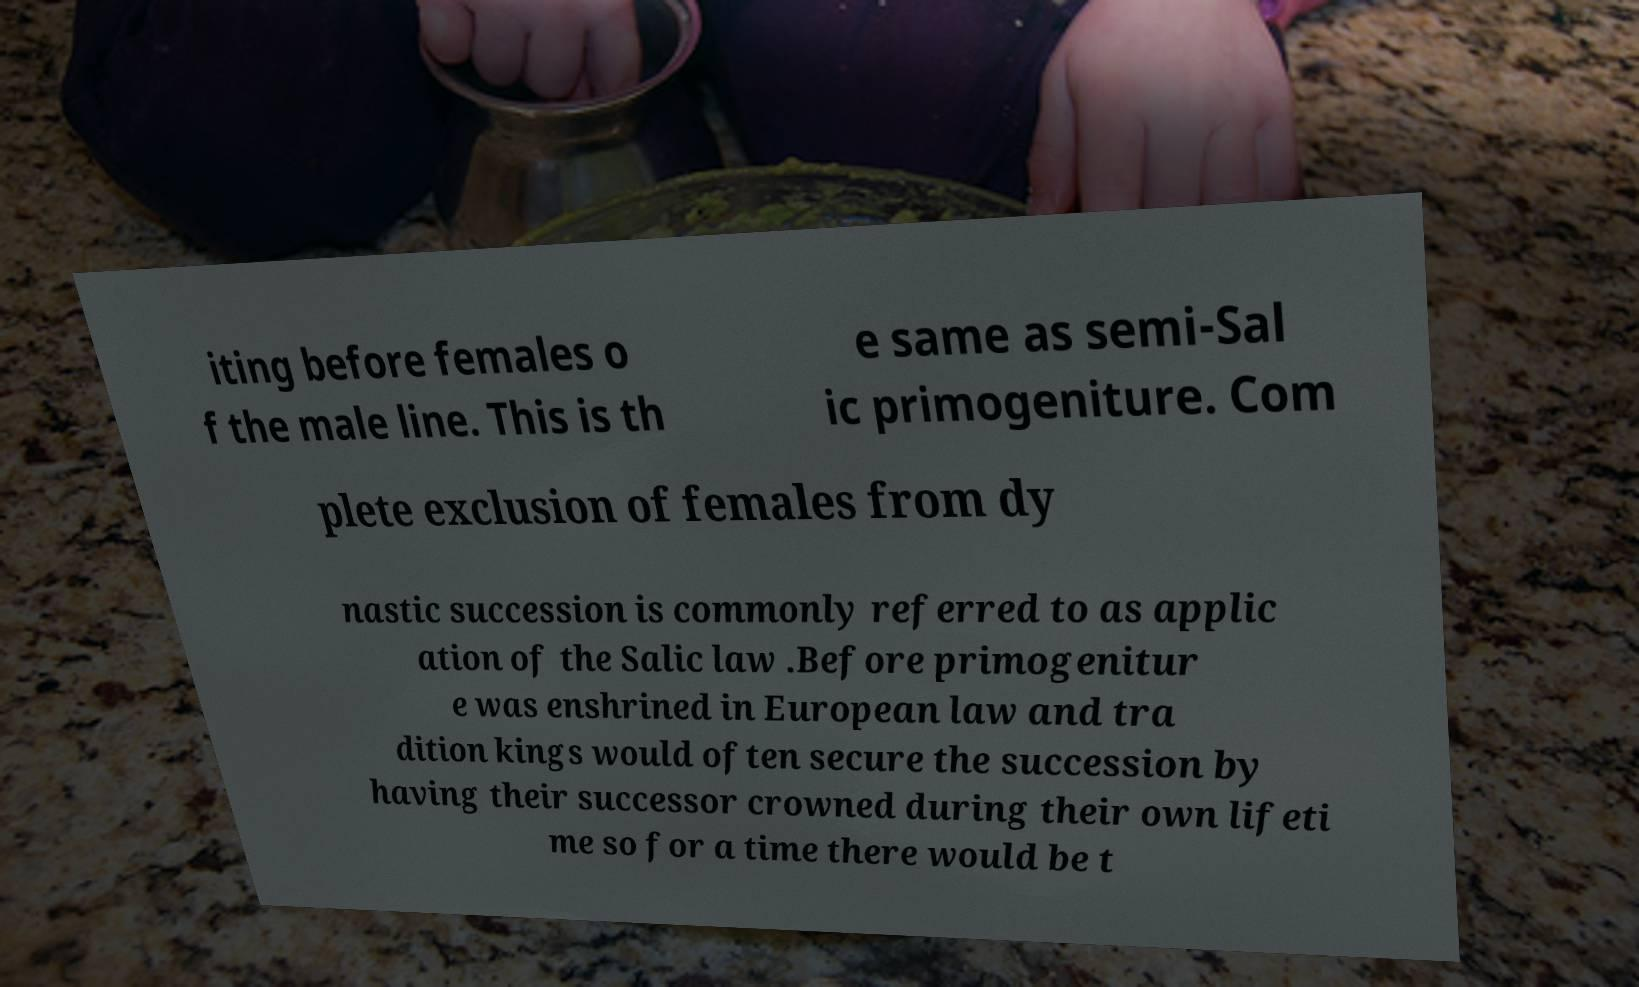Please read and relay the text visible in this image. What does it say? iting before females o f the male line. This is th e same as semi-Sal ic primogeniture. Com plete exclusion of females from dy nastic succession is commonly referred to as applic ation of the Salic law .Before primogenitur e was enshrined in European law and tra dition kings would often secure the succession by having their successor crowned during their own lifeti me so for a time there would be t 